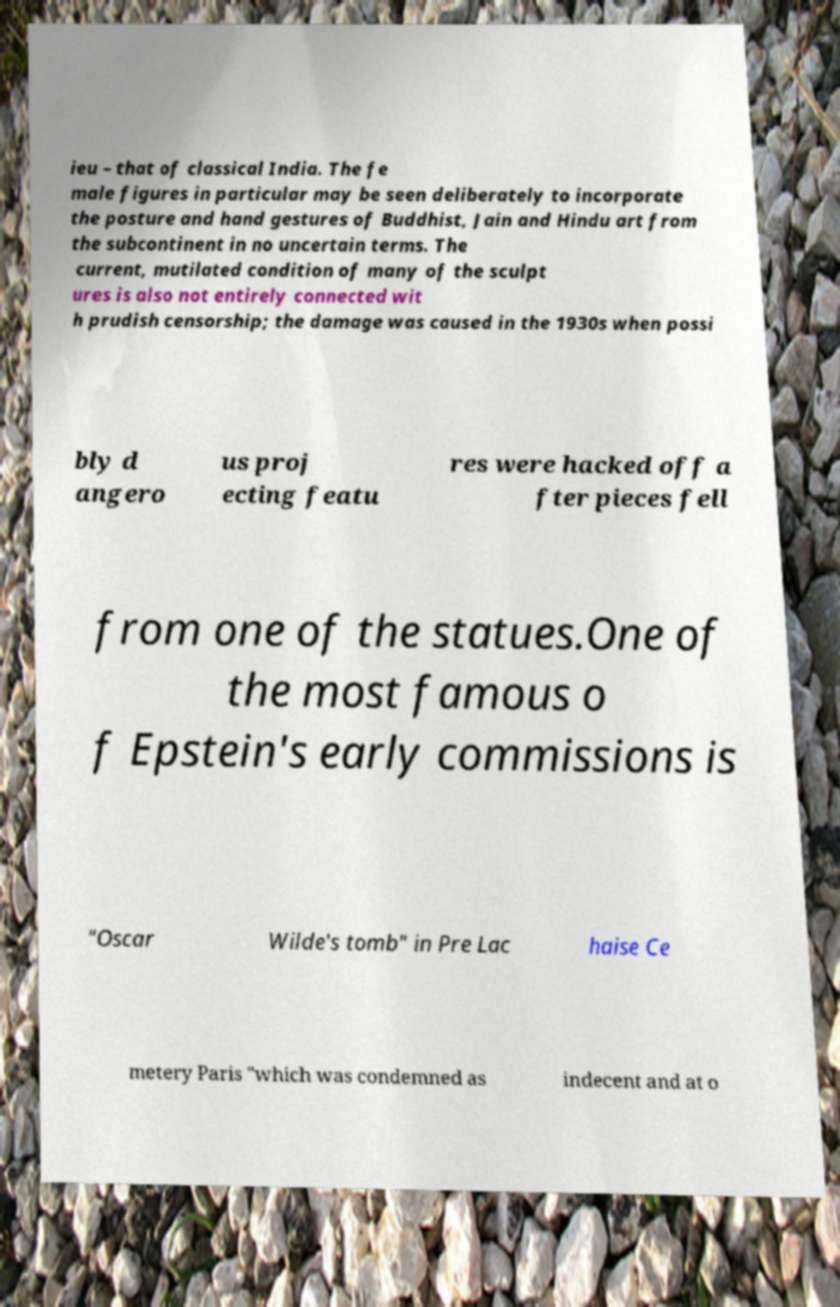Please read and relay the text visible in this image. What does it say? ieu – that of classical India. The fe male figures in particular may be seen deliberately to incorporate the posture and hand gestures of Buddhist, Jain and Hindu art from the subcontinent in no uncertain terms. The current, mutilated condition of many of the sculpt ures is also not entirely connected wit h prudish censorship; the damage was caused in the 1930s when possi bly d angero us proj ecting featu res were hacked off a fter pieces fell from one of the statues.One of the most famous o f Epstein's early commissions is "Oscar Wilde's tomb" in Pre Lac haise Ce metery Paris "which was condemned as indecent and at o 